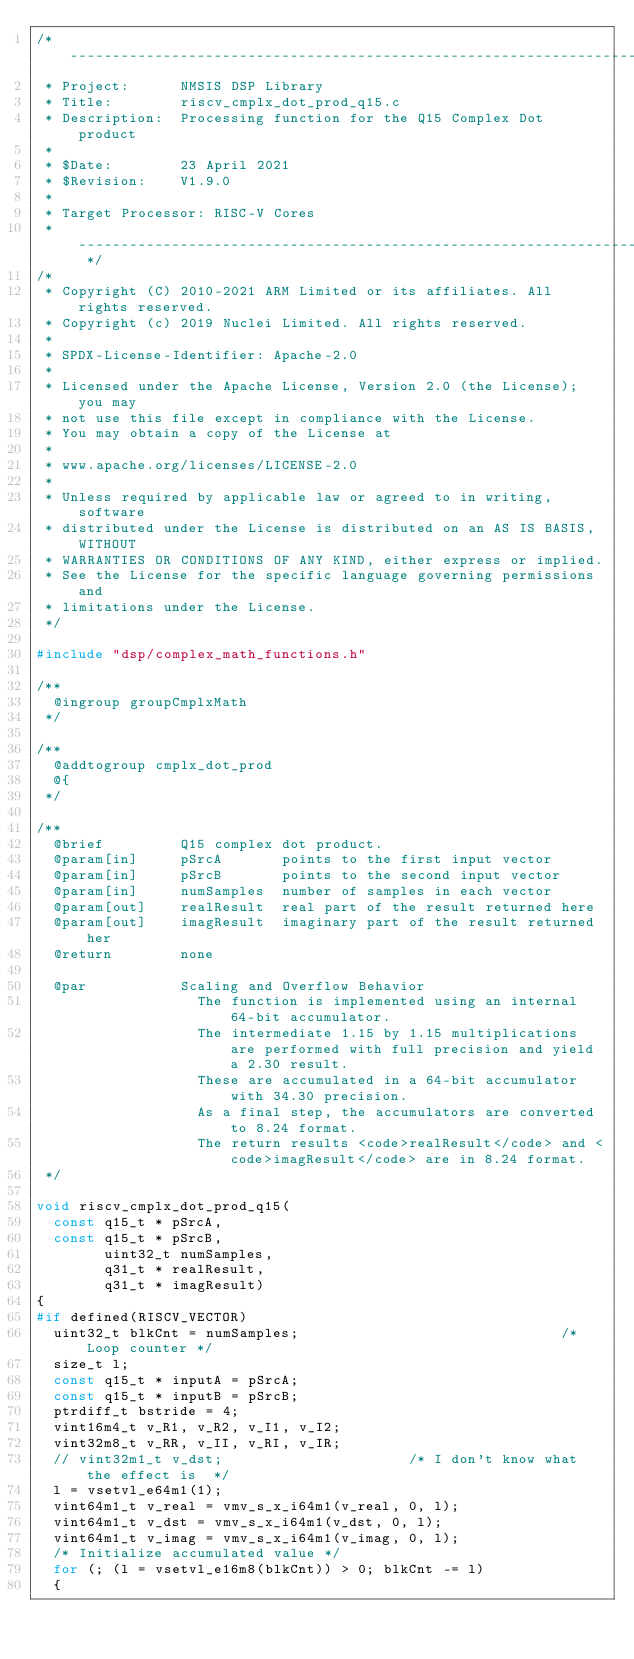Convert code to text. <code><loc_0><loc_0><loc_500><loc_500><_C_>/* ----------------------------------------------------------------------
 * Project:      NMSIS DSP Library
 * Title:        riscv_cmplx_dot_prod_q15.c
 * Description:  Processing function for the Q15 Complex Dot product
 *
 * $Date:        23 April 2021
 * $Revision:    V1.9.0
 *
 * Target Processor: RISC-V Cores
 * -------------------------------------------------------------------- */
/*
 * Copyright (C) 2010-2021 ARM Limited or its affiliates. All rights reserved.
 * Copyright (c) 2019 Nuclei Limited. All rights reserved.
 *
 * SPDX-License-Identifier: Apache-2.0
 *
 * Licensed under the Apache License, Version 2.0 (the License); you may
 * not use this file except in compliance with the License.
 * You may obtain a copy of the License at
 *
 * www.apache.org/licenses/LICENSE-2.0
 *
 * Unless required by applicable law or agreed to in writing, software
 * distributed under the License is distributed on an AS IS BASIS, WITHOUT
 * WARRANTIES OR CONDITIONS OF ANY KIND, either express or implied.
 * See the License for the specific language governing permissions and
 * limitations under the License.
 */

#include "dsp/complex_math_functions.h"

/**
  @ingroup groupCmplxMath
 */

/**
  @addtogroup cmplx_dot_prod
  @{
 */

/**
  @brief         Q15 complex dot product.
  @param[in]     pSrcA       points to the first input vector
  @param[in]     pSrcB       points to the second input vector
  @param[in]     numSamples  number of samples in each vector
  @param[out]    realResult  real part of the result returned here
  @param[out]    imagResult  imaginary part of the result returned her
  @return        none

  @par           Scaling and Overflow Behavior
                   The function is implemented using an internal 64-bit accumulator.
                   The intermediate 1.15 by 1.15 multiplications are performed with full precision and yield a 2.30 result.
                   These are accumulated in a 64-bit accumulator with 34.30 precision.
                   As a final step, the accumulators are converted to 8.24 format.
                   The return results <code>realResult</code> and <code>imagResult</code> are in 8.24 format.
 */

void riscv_cmplx_dot_prod_q15(
  const q15_t * pSrcA,
  const q15_t * pSrcB,
        uint32_t numSamples,
        q31_t * realResult,
        q31_t * imagResult)
{
#if defined(RISCV_VECTOR)
  uint32_t blkCnt = numSamples;                               /* Loop counter */
  size_t l;
  const q15_t * inputA = pSrcA;
  const q15_t * inputB = pSrcB;
  ptrdiff_t bstride = 4;
  vint16m4_t v_R1, v_R2, v_I1, v_I2;
  vint32m8_t v_RR, v_II, v_RI, v_IR;
  // vint32m1_t v_dst;                      /* I don't know what the effect is  */ 
  l = vsetvl_e64m1(1);
  vint64m1_t v_real = vmv_s_x_i64m1(v_real, 0, l);
  vint64m1_t v_dst = vmv_s_x_i64m1(v_dst, 0, l);
  vint64m1_t v_imag = vmv_s_x_i64m1(v_imag, 0, l);
  /* Initialize accumulated value */
  for (; (l = vsetvl_e16m8(blkCnt)) > 0; blkCnt -= l) 
  {</code> 